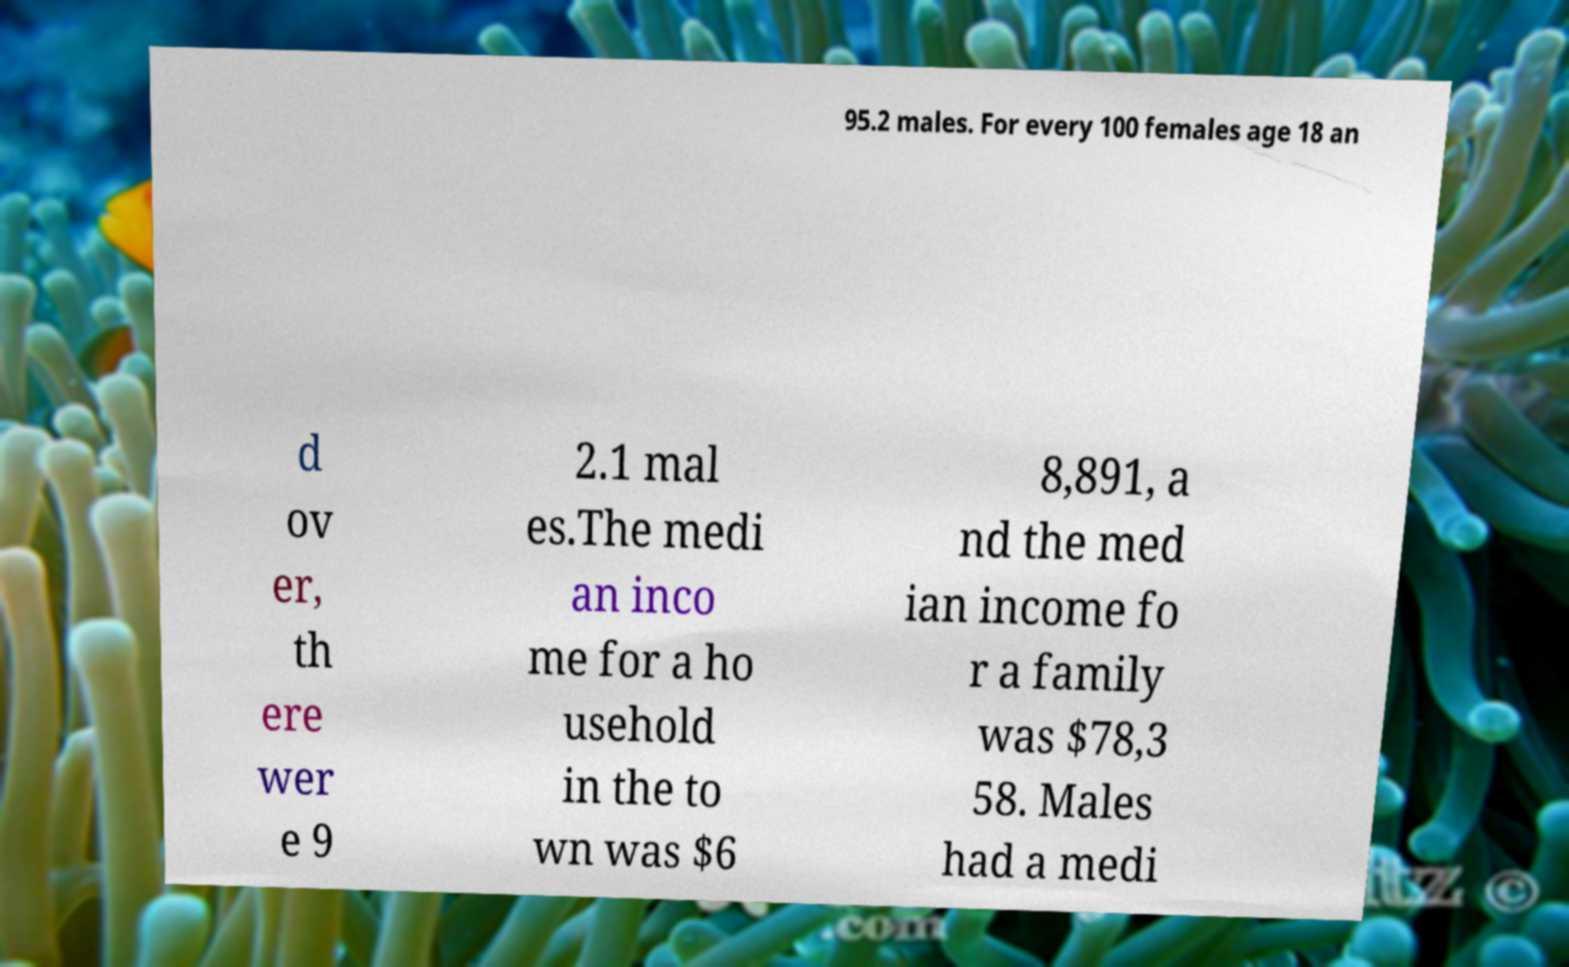I need the written content from this picture converted into text. Can you do that? 95.2 males. For every 100 females age 18 an d ov er, th ere wer e 9 2.1 mal es.The medi an inco me for a ho usehold in the to wn was $6 8,891, a nd the med ian income fo r a family was $78,3 58. Males had a medi 